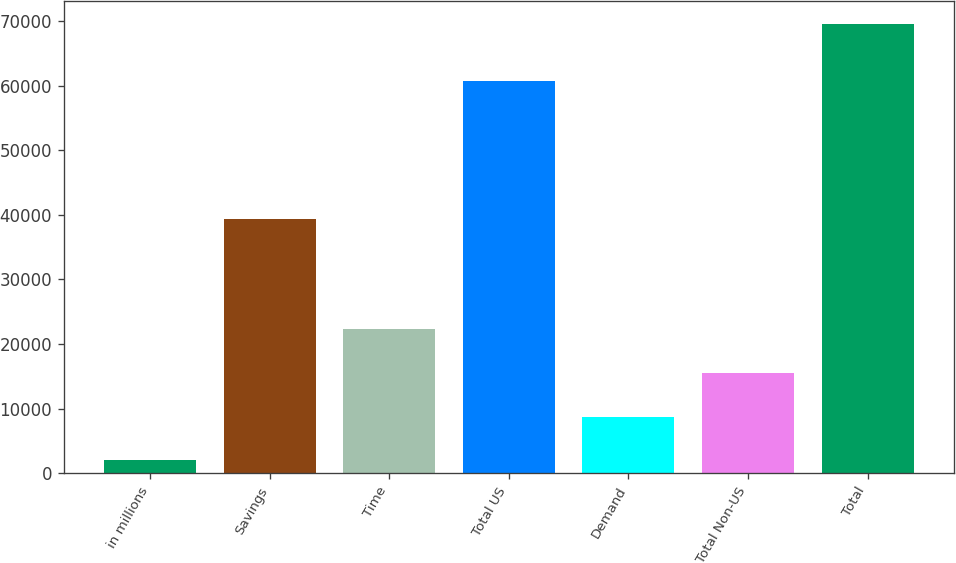Convert chart. <chart><loc_0><loc_0><loc_500><loc_500><bar_chart><fcel>in millions<fcel>Savings<fcel>Time<fcel>Total US<fcel>Demand<fcel>Total Non-US<fcel>Total<nl><fcel>2013<fcel>39411<fcel>22283.7<fcel>60699<fcel>8769.9<fcel>15526.8<fcel>69582<nl></chart> 